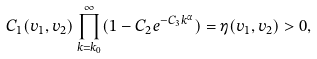<formula> <loc_0><loc_0><loc_500><loc_500>C _ { 1 } ( v _ { 1 } , v _ { 2 } ) \prod _ { k = k _ { 0 } } ^ { \infty } ( 1 - C _ { 2 } e ^ { - C _ { 3 } k ^ { \alpha } } ) = \eta ( v _ { 1 } , v _ { 2 } ) > 0 ,</formula> 